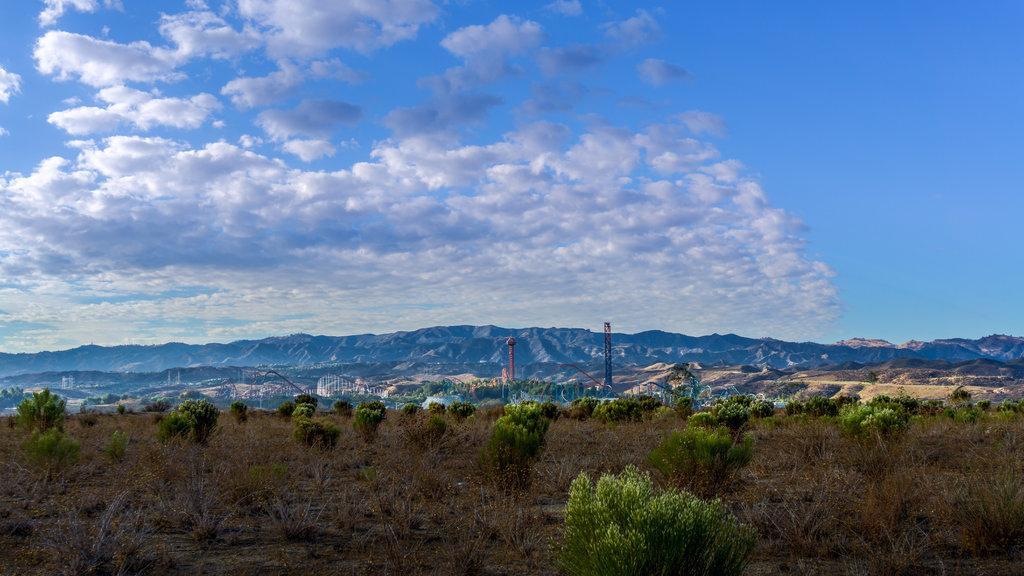Describe this image in one or two sentences. In this image we can see there are trees and mountains. And there is the fence, pole and tower. There is the sky in the background. 